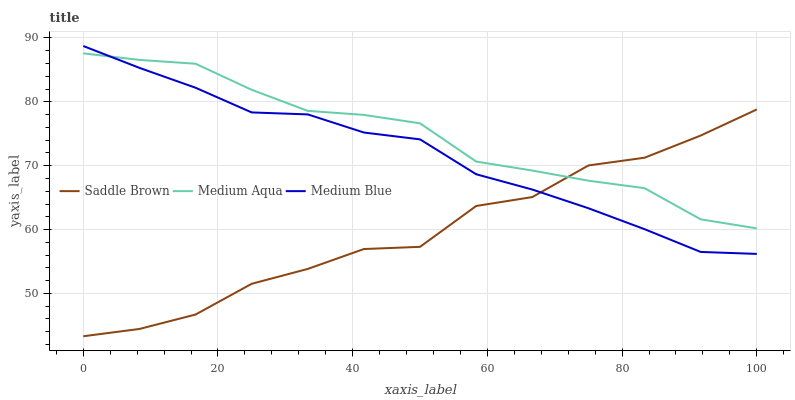Does Saddle Brown have the minimum area under the curve?
Answer yes or no. Yes. Does Medium Aqua have the maximum area under the curve?
Answer yes or no. Yes. Does Medium Aqua have the minimum area under the curve?
Answer yes or no. No. Does Saddle Brown have the maximum area under the curve?
Answer yes or no. No. Is Medium Blue the smoothest?
Answer yes or no. Yes. Is Saddle Brown the roughest?
Answer yes or no. Yes. Is Medium Aqua the smoothest?
Answer yes or no. No. Is Medium Aqua the roughest?
Answer yes or no. No. Does Saddle Brown have the lowest value?
Answer yes or no. Yes. Does Medium Aqua have the lowest value?
Answer yes or no. No. Does Medium Blue have the highest value?
Answer yes or no. Yes. Does Medium Aqua have the highest value?
Answer yes or no. No. Does Medium Blue intersect Medium Aqua?
Answer yes or no. Yes. Is Medium Blue less than Medium Aqua?
Answer yes or no. No. Is Medium Blue greater than Medium Aqua?
Answer yes or no. No. 